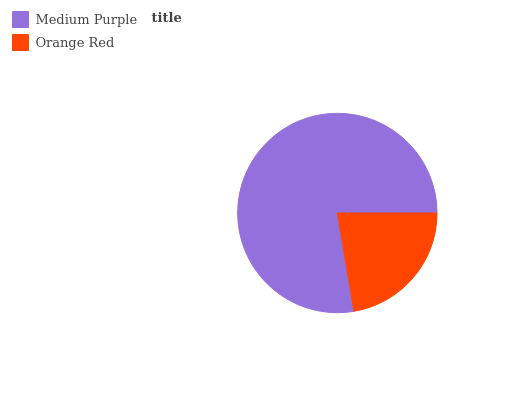Is Orange Red the minimum?
Answer yes or no. Yes. Is Medium Purple the maximum?
Answer yes or no. Yes. Is Orange Red the maximum?
Answer yes or no. No. Is Medium Purple greater than Orange Red?
Answer yes or no. Yes. Is Orange Red less than Medium Purple?
Answer yes or no. Yes. Is Orange Red greater than Medium Purple?
Answer yes or no. No. Is Medium Purple less than Orange Red?
Answer yes or no. No. Is Medium Purple the high median?
Answer yes or no. Yes. Is Orange Red the low median?
Answer yes or no. Yes. Is Orange Red the high median?
Answer yes or no. No. Is Medium Purple the low median?
Answer yes or no. No. 